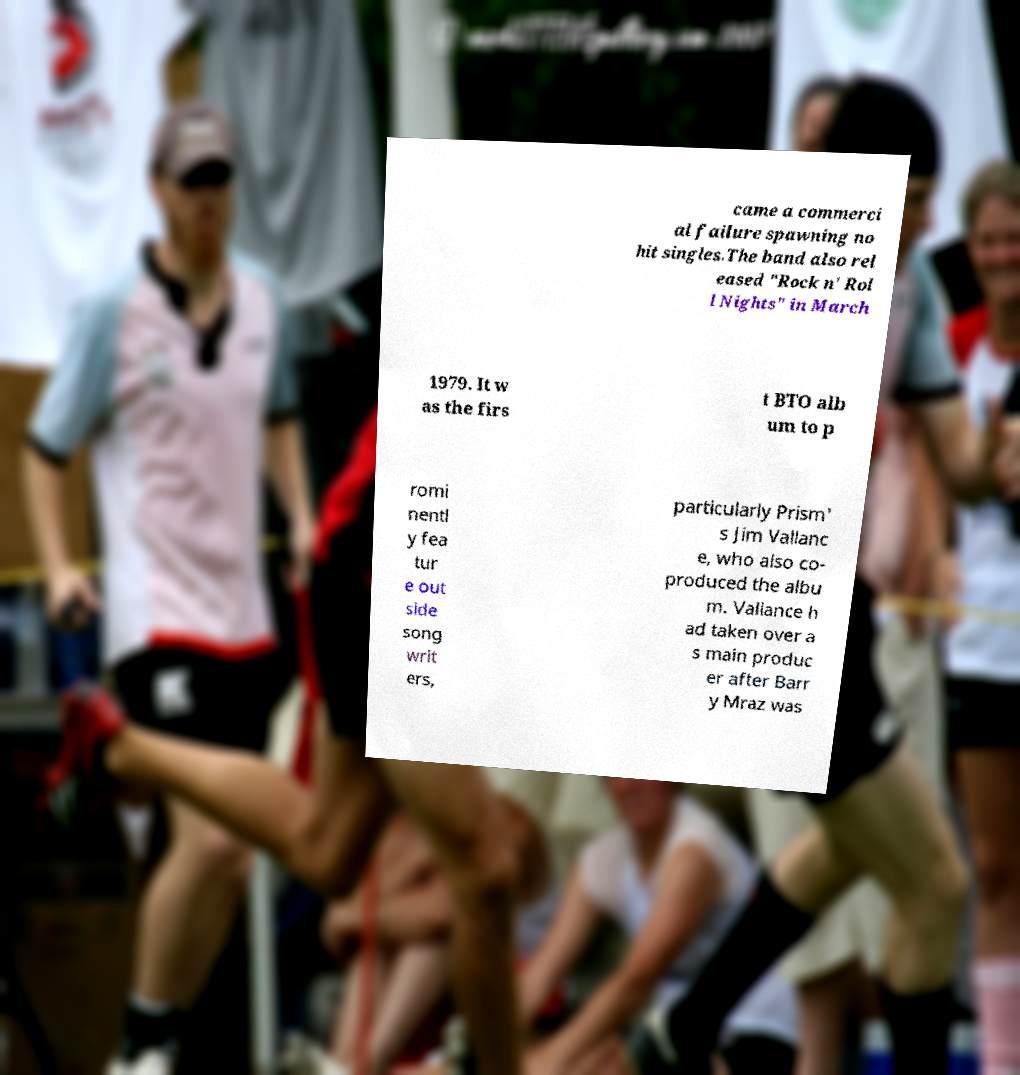I need the written content from this picture converted into text. Can you do that? came a commerci al failure spawning no hit singles.The band also rel eased "Rock n' Rol l Nights" in March 1979. It w as the firs t BTO alb um to p romi nentl y fea tur e out side song writ ers, particularly Prism' s Jim Vallanc e, who also co- produced the albu m. Vallance h ad taken over a s main produc er after Barr y Mraz was 